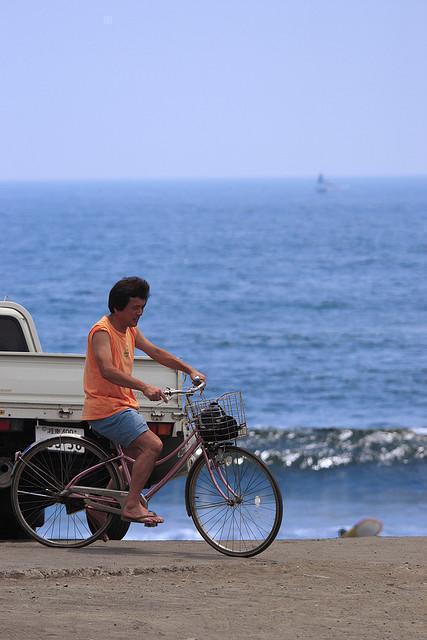What kind of power does the pink bicycle run on?
Select the accurate response from the four choices given to answer the question.
Options: Coal, electricity, man power, gas. Man power. 